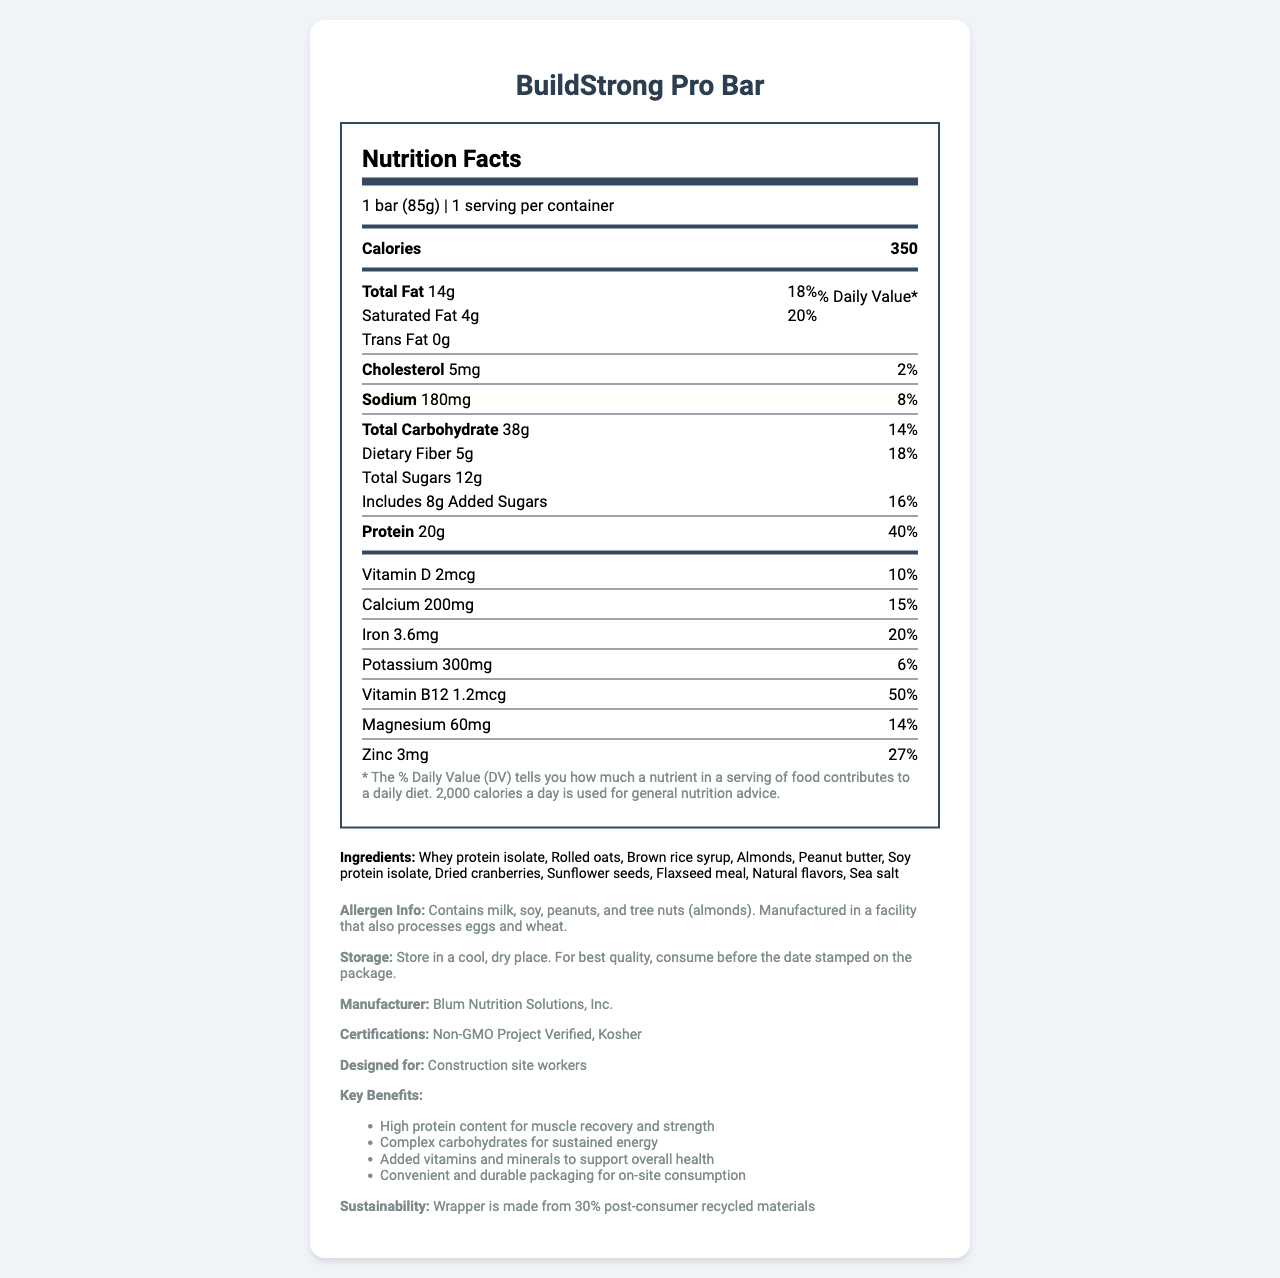what is the serving size? The serving size information is presented at the top of the document under the title "Nutrition Facts." It states "1 bar (85g)."
Answer: 1 bar (85g) how many calories does one serving contain? The calories per serving is clearly listed as 350 in the document.
Answer: 350 what is the total fat content in the bar? The total fat content is displayed as "14g" under the "Total Fat" section in the nutrition facts.
Answer: 14g what percentage of the daily value does the protein content cover? The protein content's daily value percentage is shown as "40%" next to the protein amount of "20g."
Answer: 40% what is the amount of dietary fiber per serving? The dietary fiber content is listed as "5g" under the "Total Carbohydrate" section.
Answer: 5g how much vitamin B12 does the bar contain? Vitamin B12 content is displayed in the vitamin and mineral section as "1.2mcg."
Answer: 1.2mcg what are the primary benefits of the BuildStrong Pro Bar? These key benefits are listed in the "Key Benefits" section under "additional_info."
Answer: High protein content for muscle recovery and strength, Complex carbohydrates for sustained energy, Added vitamins and minerals to support overall health, Convenient and durable packaging for on-site consumption how much calcium is in the protein bar? A. 100mg B. 150mg C. 200mg D. 250mg The calcium content is listed as "200mg" in the vitamin and mineral section.
Answer: C. 200mg what is the source of protein in the BuildStrong Pro Bar? A. Whey protein isolate B. Soy protein isolate C. Both D. Neither The ingredients list includes both "Whey protein isolate" and "Soy protein isolate."
Answer: C. Both is the BuildStrong Pro Bar suitable for someone with a tree nut allergy? The allergen information states that the bar contains tree nuts (almonds).
Answer: No summarize the document. This summary captures the primary components and purpose of the document, detailing what it contains and its intended audience.
Answer: The document is a Nutrition Facts Label for the BuildStrong Pro Bar, a protein bar designed for construction site workers. It provides details about serving size, caloric content, macronutrient and micronutrient values, and daily percentage values. Ingredients, allergen information, storage instructions, manufacturer details, and certifications are also included. The bar's key benefits and sustainability practices are highlighted, making it suitable for those needing high protein, sustained energy, and added nutritional support. does the bar contain any trans fat? The trans fat content is listed as "0g" in the nutrition facts.
Answer: No what is the daily value percentage of iron in the bar? The iron content's daily value percentage is shown as "20%" next to the iron amount of "3.6mg."
Answer: 20% who manufactures the BuildStrong Pro Bar? The manufacturer information is provided as "Blum Nutrition Solutions, Inc."
Answer: Blum Nutrition Solutions, Inc. how much potassium does the bar provide? The potassium content is listed as "300mg" in the vitamin and mineral section.
Answer: 300mg can this bar be considered low in sodium? According to general nutrition guidelines, a food item is typically considered low-sodium if it contains 140mg or less of sodium per serving. The bar contains 180mg of sodium, which is higher than this threshold.
Answer: No when should the BuildStrong Pro Bar be consumed for best quality? The storage instructions specify to consume the bar before the date stamped on the package for best quality.
Answer: Before the date stamped on the package what is the magnesium content and its daily value percentage? The magnesium content is listed as "60mg" and its daily value percentage as "14%" in the vitamin and mineral section.
Answer: 60mg, 14% how much of the wrapper material is made from post-consumer recycled materials? The sustainability section mentions that the wrapper is made from "30% post-consumer recycled materials."
Answer: 30% what is the recommended storage condition for the bar? The storage instructions recommend storing the bar in a cool, dry place.
Answer: Store in a cool, dry place who is David S. Blum? The document does not provide any information about David S. Blum.
Answer: Cannot be determined 